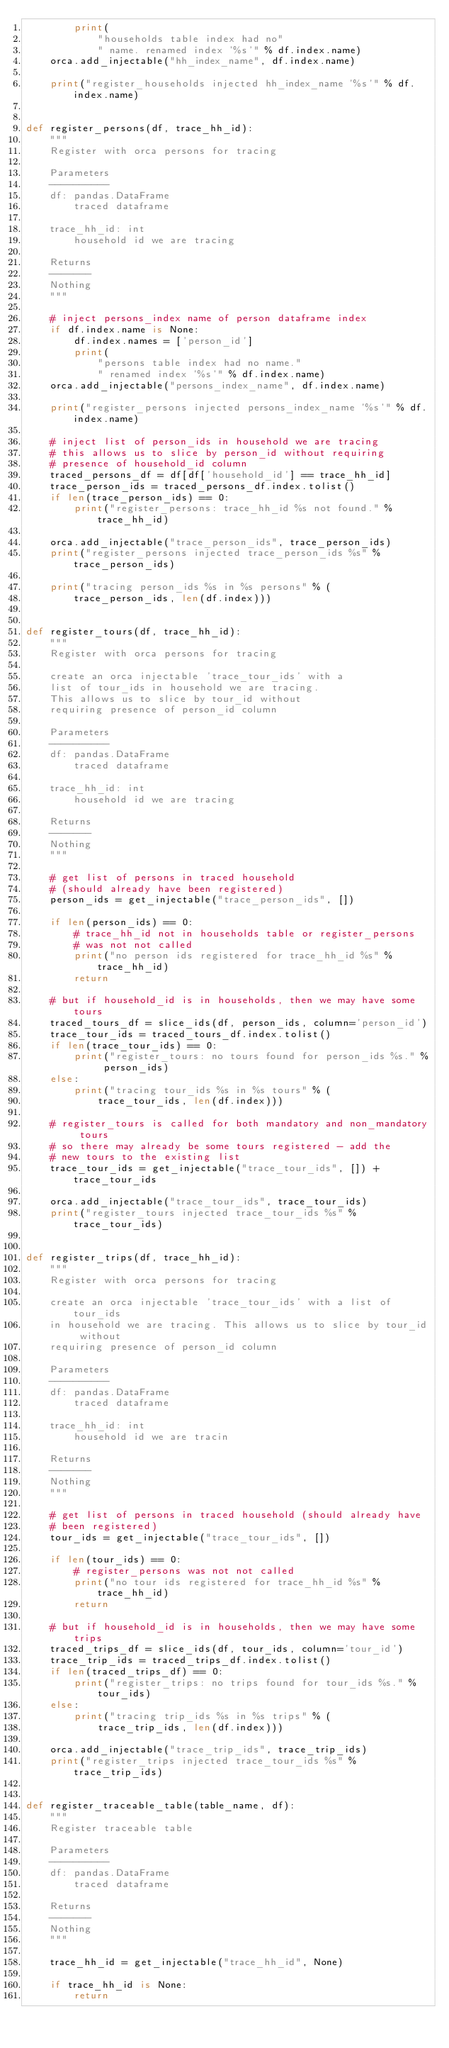<code> <loc_0><loc_0><loc_500><loc_500><_Python_>        print(
            "households table index had no"
            " name. renamed index '%s'" % df.index.name)
    orca.add_injectable("hh_index_name", df.index.name)

    print("register_households injected hh_index_name '%s'" % df.index.name)


def register_persons(df, trace_hh_id):
    """
    Register with orca persons for tracing

    Parameters
    ----------
    df: pandas.DataFrame
        traced dataframe

    trace_hh_id: int
        household id we are tracing

    Returns
    -------
    Nothing
    """

    # inject persons_index name of person dataframe index
    if df.index.name is None:
        df.index.names = ['person_id']
        print(
            "persons table index had no name."
            " renamed index '%s'" % df.index.name)
    orca.add_injectable("persons_index_name", df.index.name)

    print("register_persons injected persons_index_name '%s'" % df.index.name)

    # inject list of person_ids in household we are tracing
    # this allows us to slice by person_id without requiring
    # presence of household_id column
    traced_persons_df = df[df['household_id'] == trace_hh_id]
    trace_person_ids = traced_persons_df.index.tolist()
    if len(trace_person_ids) == 0:
        print("register_persons: trace_hh_id %s not found." % trace_hh_id)

    orca.add_injectable("trace_person_ids", trace_person_ids)
    print("register_persons injected trace_person_ids %s" % trace_person_ids)

    print("tracing person_ids %s in %s persons" % (
        trace_person_ids, len(df.index)))


def register_tours(df, trace_hh_id):
    """
    Register with orca persons for tracing

    create an orca injectable 'trace_tour_ids' with a
    list of tour_ids in household we are tracing.
    This allows us to slice by tour_id without
    requiring presence of person_id column

    Parameters
    ----------
    df: pandas.DataFrame
        traced dataframe

    trace_hh_id: int
        household id we are tracing

    Returns
    -------
    Nothing
    """

    # get list of persons in traced household
    # (should already have been registered)
    person_ids = get_injectable("trace_person_ids", [])

    if len(person_ids) == 0:
        # trace_hh_id not in households table or register_persons
        # was not not called
        print("no person ids registered for trace_hh_id %s" % trace_hh_id)
        return

    # but if household_id is in households, then we may have some tours
    traced_tours_df = slice_ids(df, person_ids, column='person_id')
    trace_tour_ids = traced_tours_df.index.tolist()
    if len(trace_tour_ids) == 0:
        print("register_tours: no tours found for person_ids %s." % person_ids)
    else:
        print("tracing tour_ids %s in %s tours" % (
            trace_tour_ids, len(df.index)))

    # register_tours is called for both mandatory and non_mandatory tours
    # so there may already be some tours registered - add the
    # new tours to the existing list
    trace_tour_ids = get_injectable("trace_tour_ids", []) + trace_tour_ids

    orca.add_injectable("trace_tour_ids", trace_tour_ids)
    print("register_tours injected trace_tour_ids %s" % trace_tour_ids)


def register_trips(df, trace_hh_id):
    """
    Register with orca persons for tracing

    create an orca injectable 'trace_tour_ids' with a list of tour_ids
    in household we are tracing. This allows us to slice by tour_id without
    requiring presence of person_id column

    Parameters
    ----------
    df: pandas.DataFrame
        traced dataframe

    trace_hh_id: int
        household id we are tracin

    Returns
    -------
    Nothing
    """

    # get list of persons in traced household (should already have
    # been registered)
    tour_ids = get_injectable("trace_tour_ids", [])

    if len(tour_ids) == 0:
        # register_persons was not not called
        print("no tour ids registered for trace_hh_id %s" % trace_hh_id)
        return

    # but if household_id is in households, then we may have some trips
    traced_trips_df = slice_ids(df, tour_ids, column='tour_id')
    trace_trip_ids = traced_trips_df.index.tolist()
    if len(traced_trips_df) == 0:
        print("register_trips: no trips found for tour_ids %s." % tour_ids)
    else:
        print("tracing trip_ids %s in %s trips" % (
            trace_trip_ids, len(df.index)))

    orca.add_injectable("trace_trip_ids", trace_trip_ids)
    print("register_trips injected trace_tour_ids %s" % trace_trip_ids)


def register_traceable_table(table_name, df):
    """
    Register traceable table

    Parameters
    ----------
    df: pandas.DataFrame
        traced dataframe

    Returns
    -------
    Nothing
    """

    trace_hh_id = get_injectable("trace_hh_id", None)

    if trace_hh_id is None:
        return
</code> 